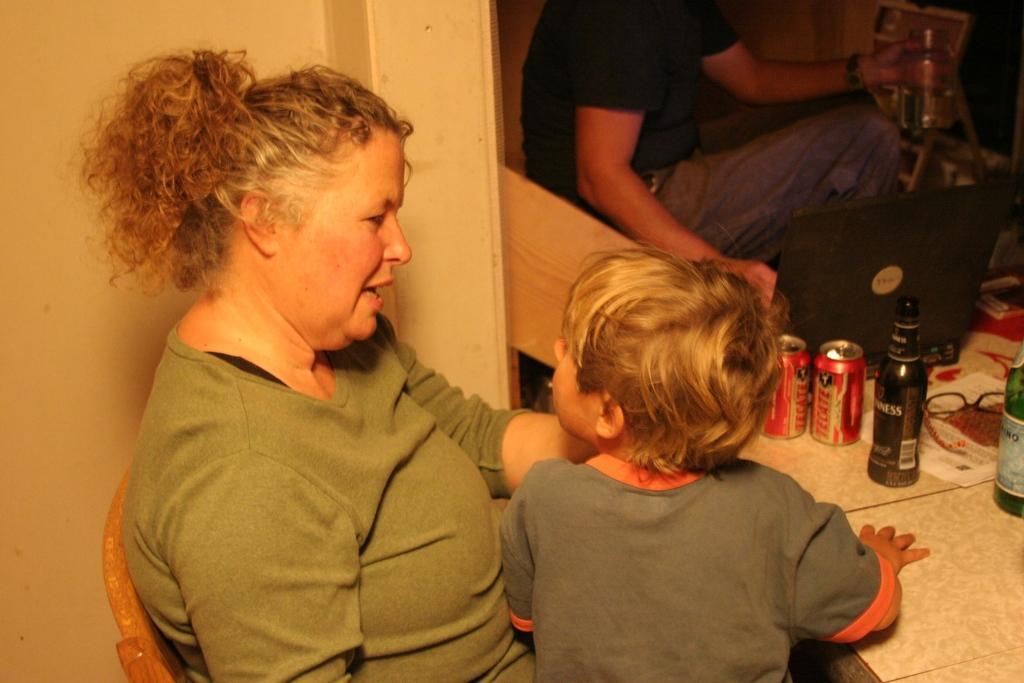In one or two sentences, can you explain what this image depicts? In this picture there is a woman sitting on the chair and there is a boy. At the back there is a man sitting and holding the object and there is a laptop and there are bottles, tins and there are papers and there is a spectacles on the table. 